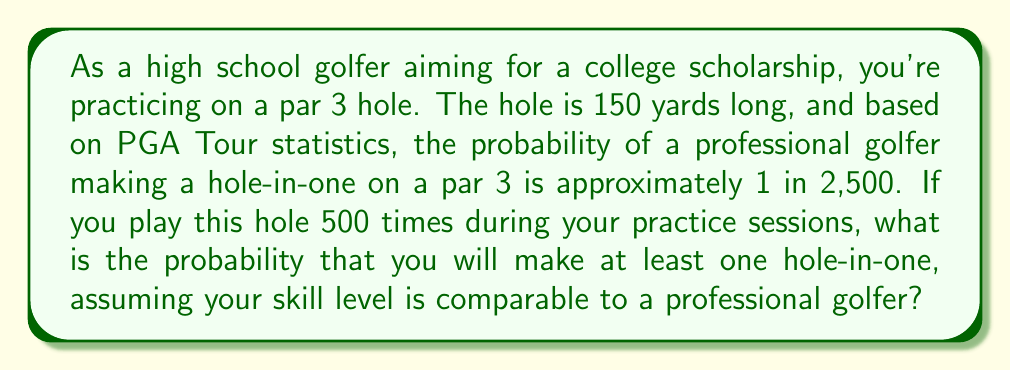Solve this math problem. Let's approach this step-by-step:

1) First, we need to calculate the probability of NOT making a hole-in-one on a single attempt:
   $P(\text{no hole-in-one}) = 1 - P(\text{hole-in-one}) = 1 - \frac{1}{2500} = \frac{2499}{2500}$

2) Now, we need to calculate the probability of NOT making a hole-in-one in all 500 attempts:
   $P(\text{no hole-in-one in 500 attempts}) = (\frac{2499}{2500})^{500}$

3) The probability of making at least one hole-in-one is the complement of making no hole-in-ones:
   $P(\text{at least one hole-in-one}) = 1 - P(\text{no hole-in-one in 500 attempts})$

4) Let's calculate this:
   $P(\text{at least one hole-in-one}) = 1 - (\frac{2499}{2500})^{500}$

5) Using a calculator (as this involves a large exponent):
   $(\frac{2499}{2500})^{500} \approx 0.8187$

6) Therefore:
   $P(\text{at least one hole-in-one}) = 1 - 0.8187 \approx 0.1813$

7) Converting to a percentage:
   $0.1813 \times 100\% = 18.13\%$
Answer: The probability of making at least one hole-in-one in 500 attempts is approximately $18.13\%$ or $0.1813$. 